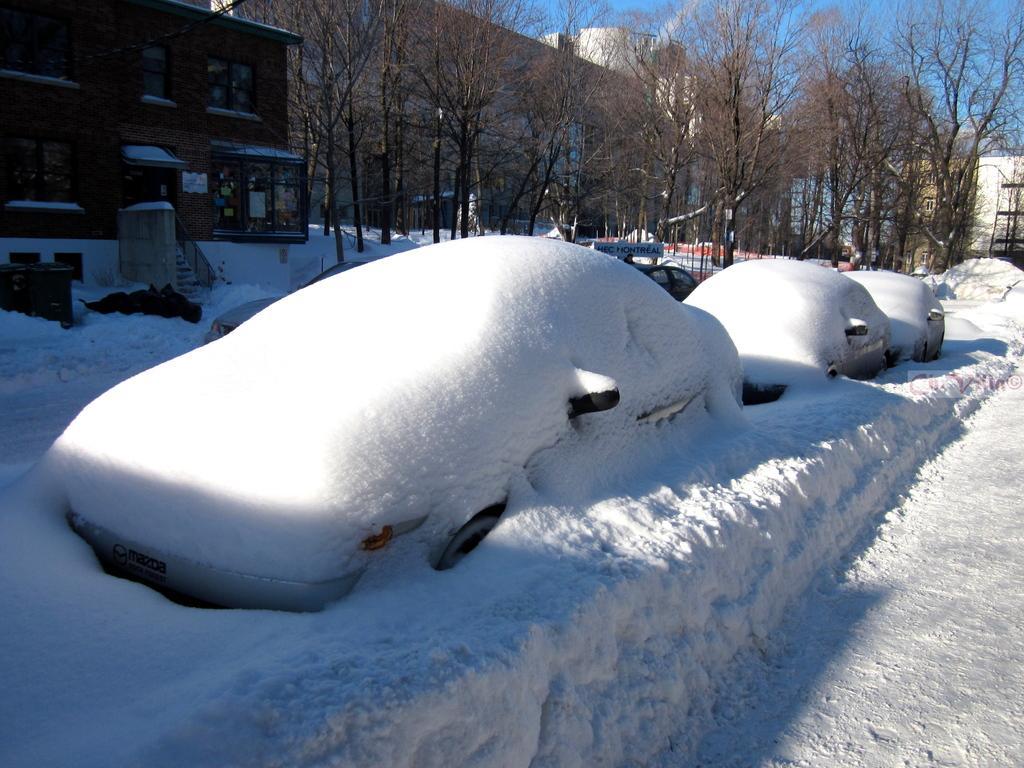Please provide a concise description of this image. In this image we can see few vehicles covered with snow, there are few buildings, trees, few objects near a building and the sky in the background. 